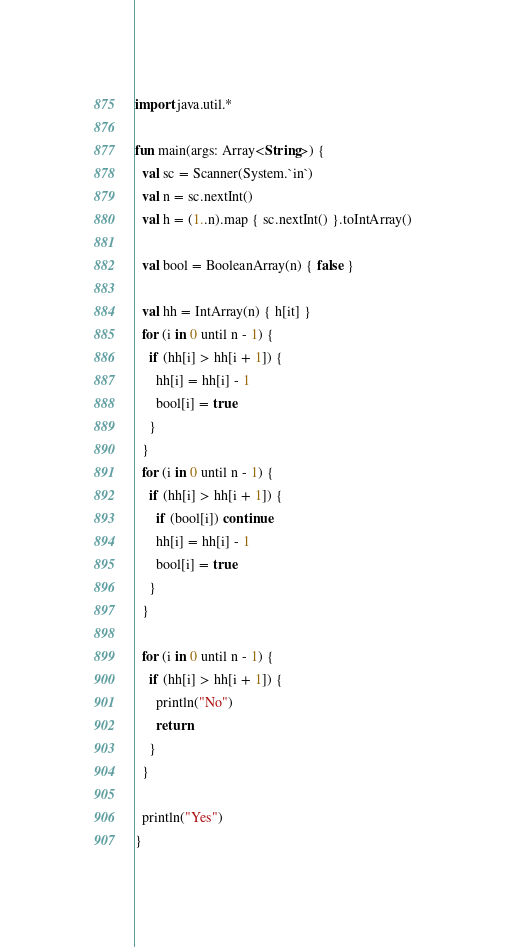<code> <loc_0><loc_0><loc_500><loc_500><_Kotlin_>import java.util.*

fun main(args: Array<String>) {
  val sc = Scanner(System.`in`)
  val n = sc.nextInt()
  val h = (1..n).map { sc.nextInt() }.toIntArray()

  val bool = BooleanArray(n) { false }

  val hh = IntArray(n) { h[it] }
  for (i in 0 until n - 1) {
    if (hh[i] > hh[i + 1]) {
      hh[i] = hh[i] - 1
      bool[i] = true
    }
  }
  for (i in 0 until n - 1) {
    if (hh[i] > hh[i + 1]) {
      if (bool[i]) continue
      hh[i] = hh[i] - 1
      bool[i] = true
    }
  }

  for (i in 0 until n - 1) {
    if (hh[i] > hh[i + 1]) {
      println("No")
      return
    }
  }

  println("Yes")
}</code> 